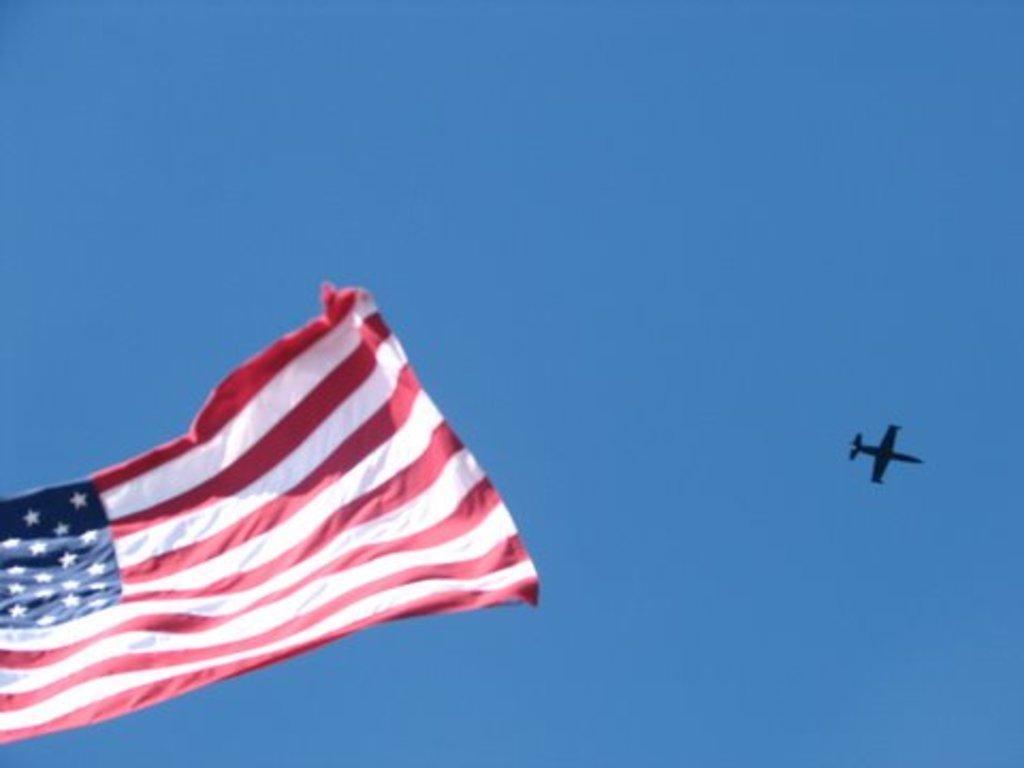Please provide a concise description of this image. In this image there is a flag. To the right there is an airplane in the air. In the background there is the sky. 